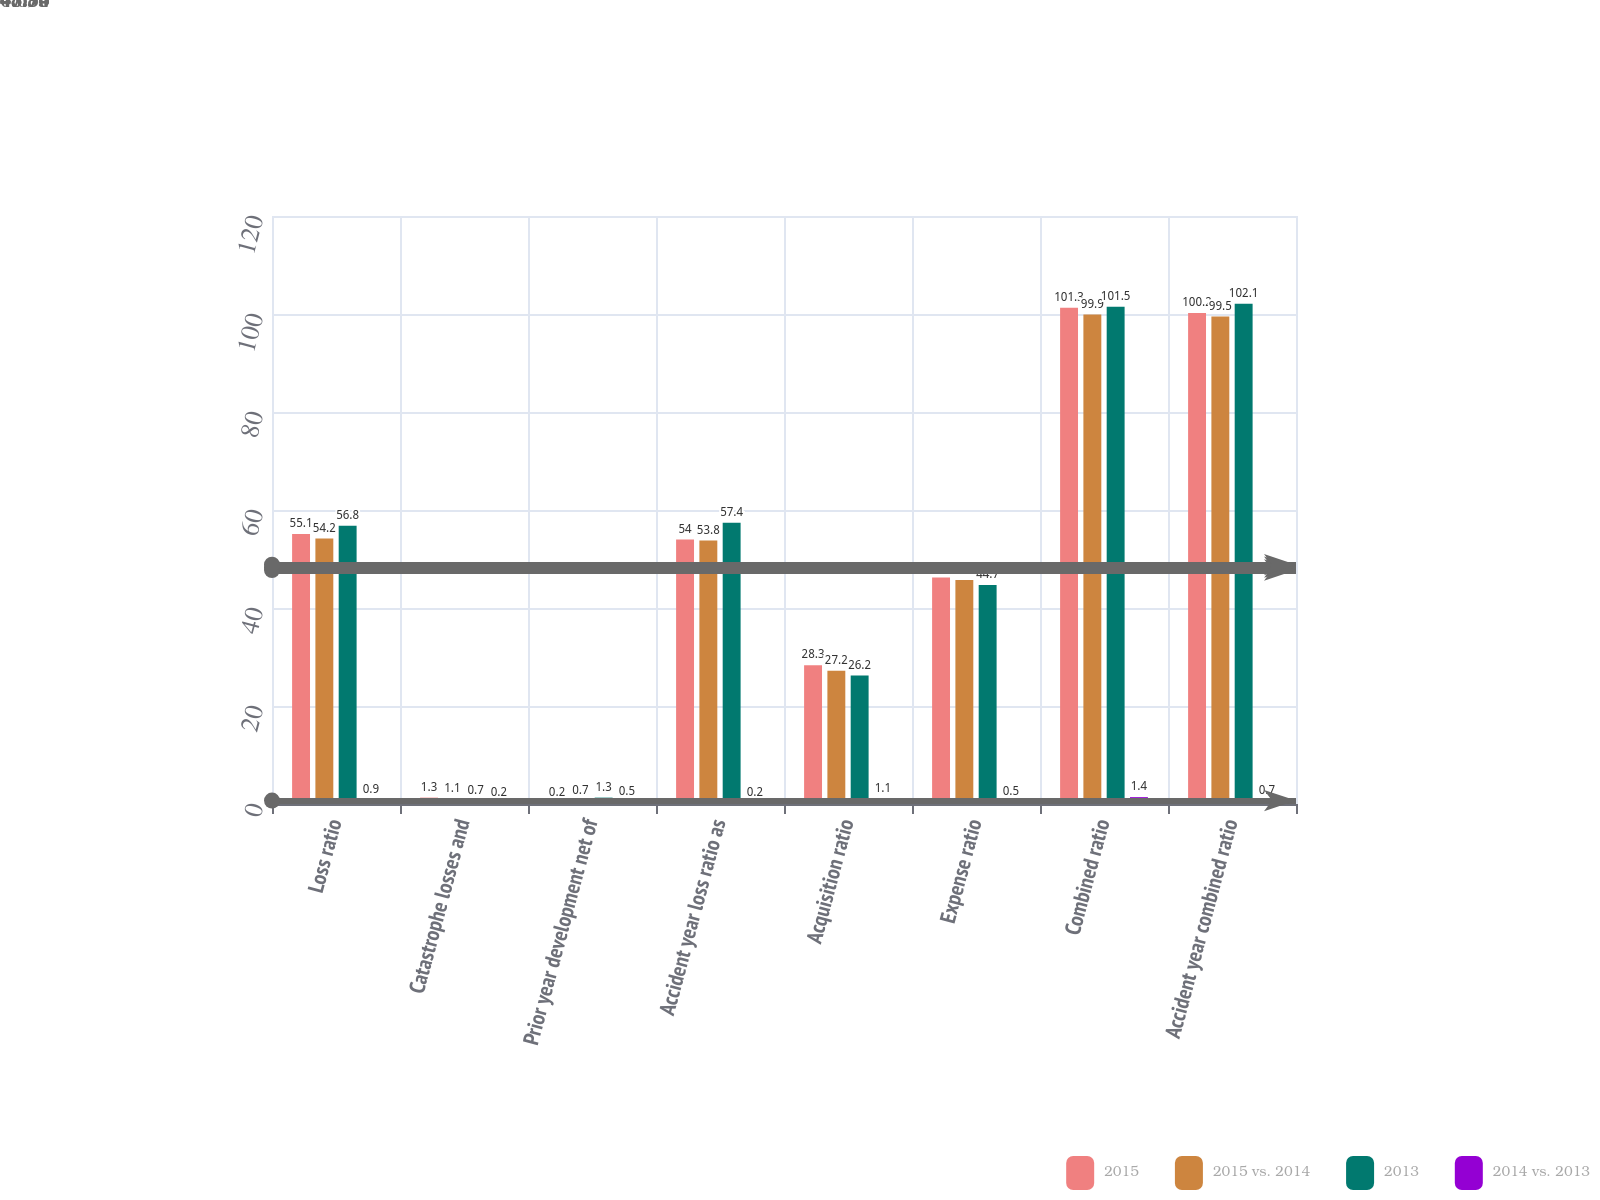<chart> <loc_0><loc_0><loc_500><loc_500><stacked_bar_chart><ecel><fcel>Loss ratio<fcel>Catastrophe losses and<fcel>Prior year development net of<fcel>Accident year loss ratio as<fcel>Acquisition ratio<fcel>Expense ratio<fcel>Combined ratio<fcel>Accident year combined ratio<nl><fcel>2015<fcel>55.1<fcel>1.3<fcel>0.2<fcel>54<fcel>28.3<fcel>46.2<fcel>101.3<fcel>100.2<nl><fcel>2015 vs. 2014<fcel>54.2<fcel>1.1<fcel>0.7<fcel>53.8<fcel>27.2<fcel>45.7<fcel>99.9<fcel>99.5<nl><fcel>2013<fcel>56.8<fcel>0.7<fcel>1.3<fcel>57.4<fcel>26.2<fcel>44.7<fcel>101.5<fcel>102.1<nl><fcel>2014 vs. 2013<fcel>0.9<fcel>0.2<fcel>0.5<fcel>0.2<fcel>1.1<fcel>0.5<fcel>1.4<fcel>0.7<nl></chart> 